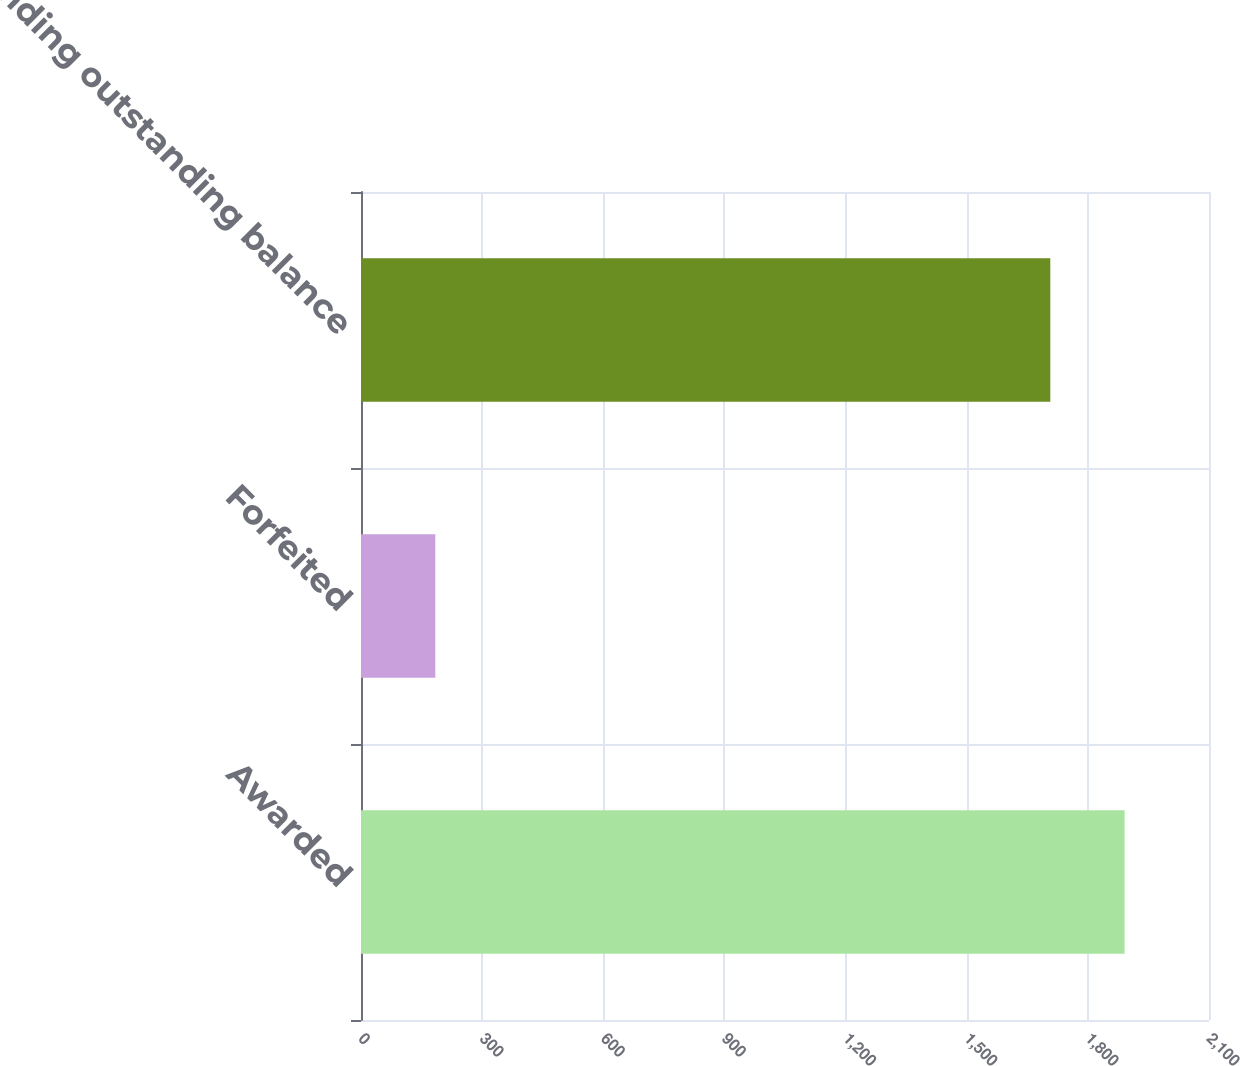Convert chart. <chart><loc_0><loc_0><loc_500><loc_500><bar_chart><fcel>Awarded<fcel>Forfeited<fcel>Ending outstanding balance<nl><fcel>1891<fcel>184<fcel>1707<nl></chart> 